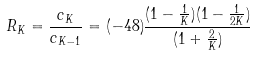<formula> <loc_0><loc_0><loc_500><loc_500>R _ { K } = \frac { c _ { K } } { c _ { K - 1 } } = ( - 4 8 ) \frac { ( 1 - \frac { 1 } { K } ) ( 1 - \frac { 1 } { 2 K } ) } { ( 1 + \frac { 2 } { K } ) }</formula> 